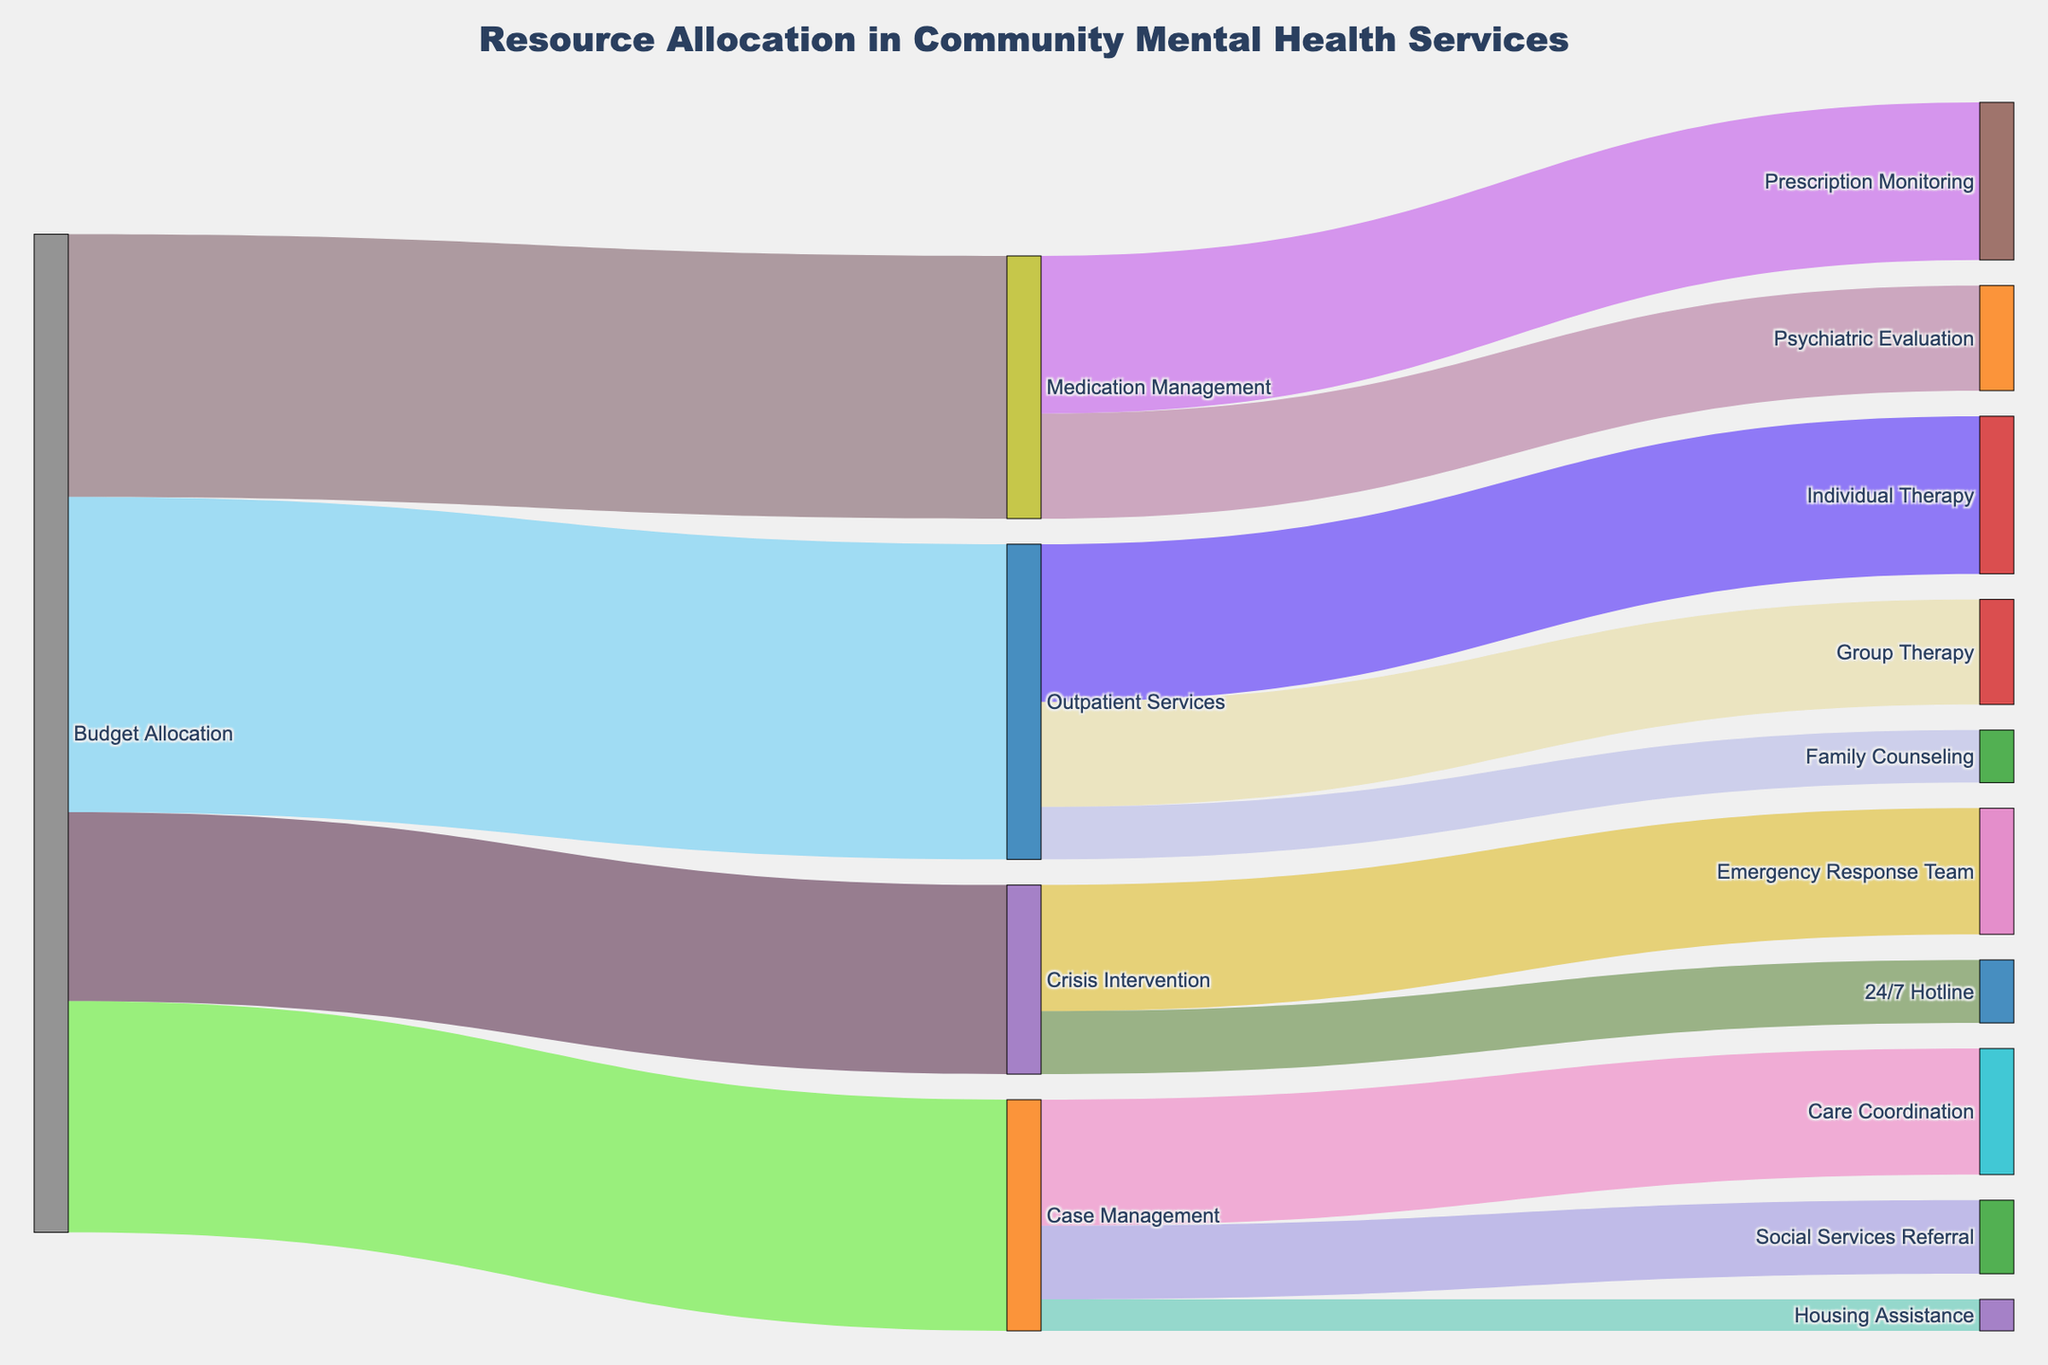What's the total budget allocated to all departments? Sum the values allocated to each department: Medication Management (250000), Crisis Intervention (180000), Outpatient Services (300000), Case Management (220000). Adding them: 250000 + 180000 + 300000 + 220000 = 950000
Answer: 950000 What is the largest funding allocation within Medication Management? Compare the values allocated to Psychiatric Evaluation (100000) and Prescription Monitoring (150000). The largest value is 150000
Answer: Prescription Monitoring How much budget is assigned to Crisis Intervention as compared to Case Management? Compare the allocated budgets for Crisis Intervention (180000) and Case Management (220000). Case Management (220000) has a higher allocation than Crisis Intervention (180000)
Answer: Case Management What's the proportion of the budget allocated to the 24/7 Hotline within Crisis Intervention? Divide the budget for the 24/7 Hotline (60000) by the total for Crisis Intervention (180000): 60000 / 180000 = 1/3 or approximately 0.33
Answer: 0.33 Which program in Outpatient Services receives the least funding? Compare budget values for Individual Therapy (150000), Group Therapy (100000), and Family Counseling (50000). Family Counseling has the smallest budget (50000)
Answer: Family Counseling How does the budget for Prescription Monitoring compare to the entire Crisis Intervention allocation? Compare Prescription Monitoring's budget (150000) to Crisis Intervention's total (180000). Crisis Intervention has a larger allocation, 180000 > 150000
Answer: Crisis Intervention How many distinct programs are represented in the figure? Count unique target programs across all departments: Psychiatric Evaluation, Prescription Monitoring, Emergency Response Team, 24/7 Hotline, Individual Therapy, Group Therapy, Family Counseling, Care Coordination, Social Services Referral, Housing Assistance. There are 10 distinct programs
Answer: 10 Which element has the highest total budget allocation and what is its value? Compare total allocations: Outpatient Services (300000), the highest allocation with value 300000
Answer: Outpatient Services, 300000 Add up the budgets for Individual Therapy and Group Therapy in Outpatient Services. What's the sum? Sum the values for Individual Therapy (150000) and Group Therapy (100000): 150000 + 100000 = 250000
Answer: 250000 Identify the least funded element in the entire dataset. Compare all values: Psychiatric Evaluation (100000), Prescription Monitoring (150000), Emergency Response Team (120000), 24/7 Hotline (60000), Individual Therapy (150000), Group Therapy (100000), Family Counseling (50000), Care Coordination (120000), Social Services Referral (70000), Housing Assistance (30000). Housing Assistance is the lowest funded with 30000
Answer: Housing Assistance 